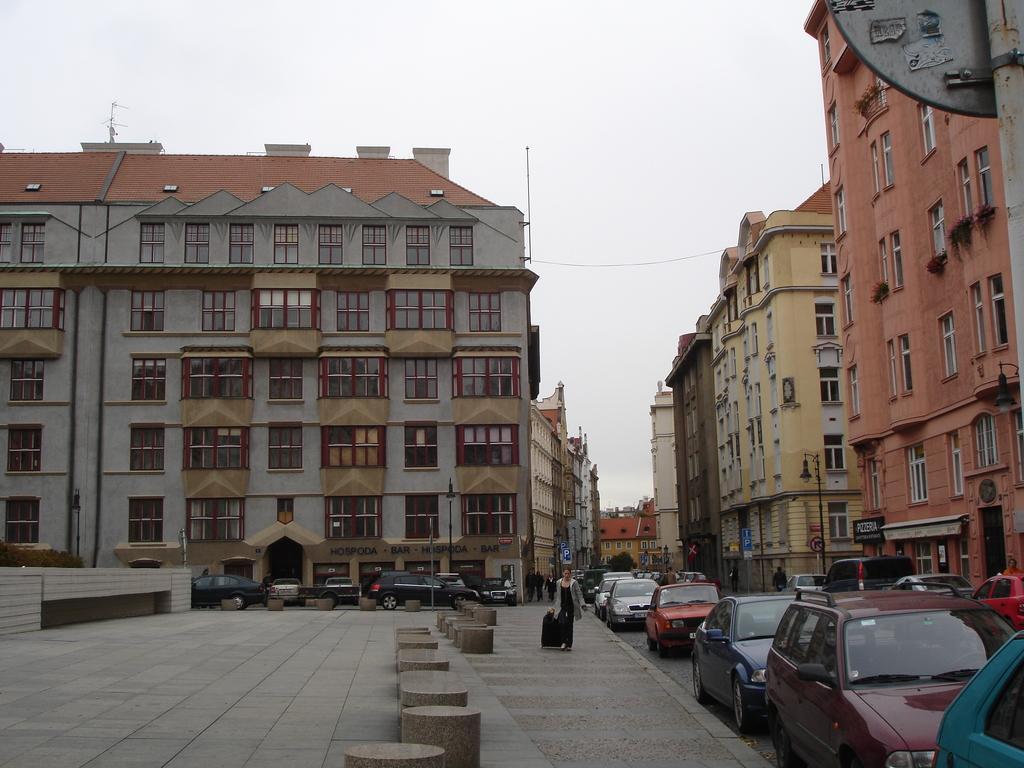Can you describe this image briefly? In the background we can see the sky. In this picture we can see buildings, windows, boards, lights, objects, poles, people and vehicles. In this picture we can see a person is holding a luggage bag. 